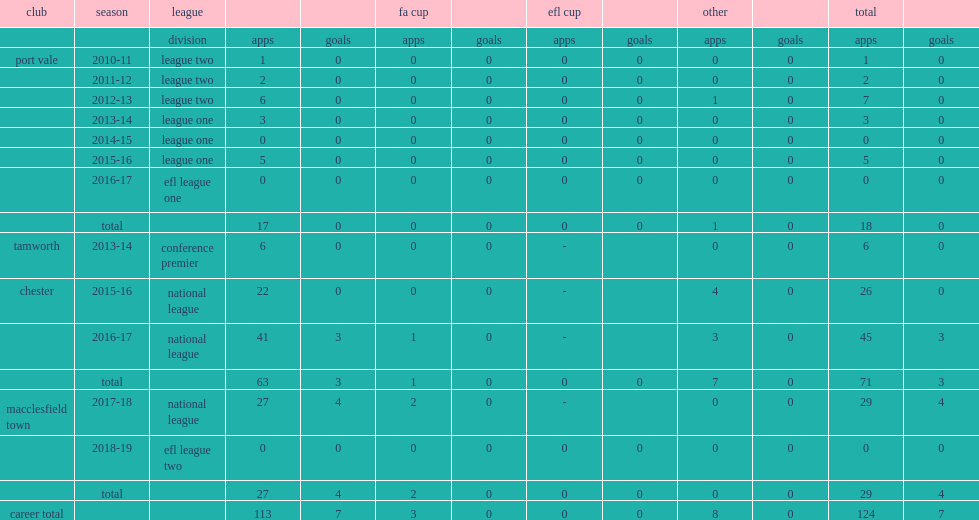Which club did ryan lloyd sign in the 2017-18 national league? Macclesfield town. 